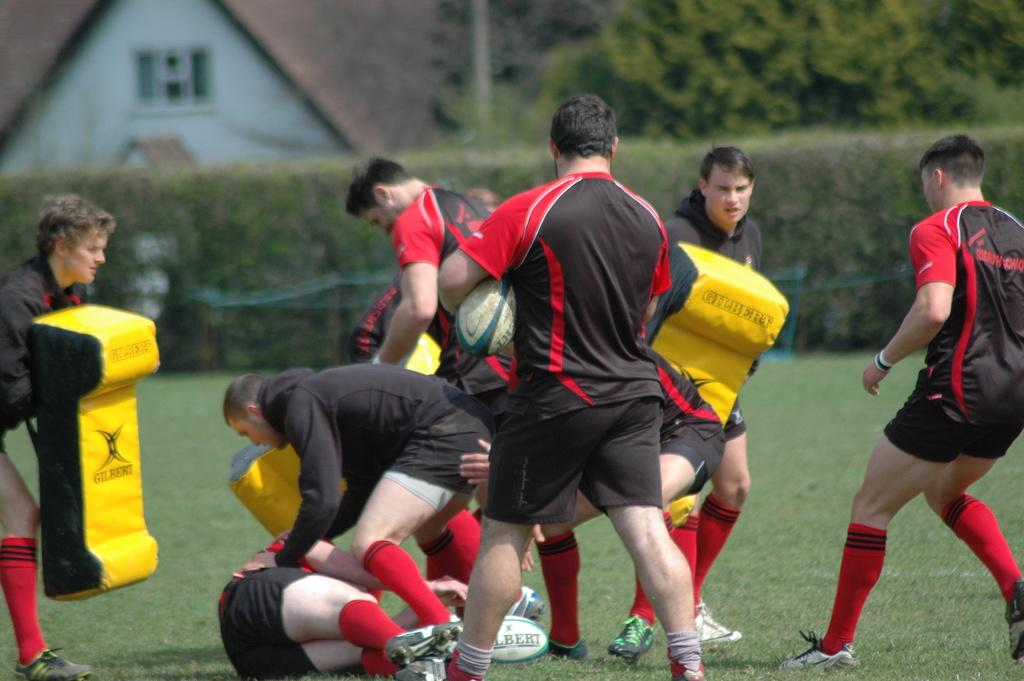How many people are in the image? There is a group of persons in the image. What are the persons wearing? The persons are wearing similar dress. What activity are the persons engaged in? The persons are playing a sport. What can be seen in the background of the image? There are trees and a house in the background of the image. What type of beef is being served at the fictional event in the image? There is no mention of beef or a fictional event in the image; it features a group of persons playing a sport. 